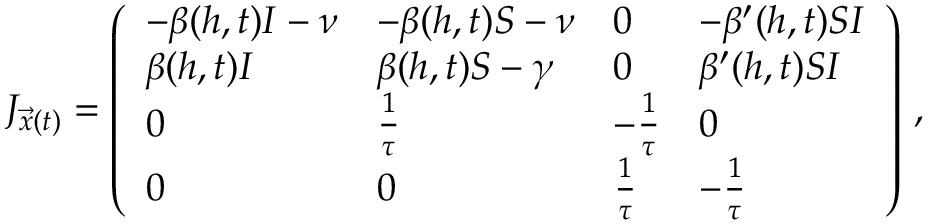Convert formula to latex. <formula><loc_0><loc_0><loc_500><loc_500>J _ { \vec { x } ( t ) } = \left ( \begin{array} { l l l l } { - \beta ( h , t ) I - \nu } & { - \beta ( h , t ) S - \nu } & { 0 } & { - \beta ^ { \prime } ( h , t ) S I } \\ { \beta ( h , t ) I } & { \beta ( h , t ) S - \gamma } & { 0 } & { \beta ^ { \prime } ( h , t ) S I } \\ { 0 } & { \frac { 1 } { \tau } } & { - \frac { 1 } { \tau } } & { 0 } \\ { 0 } & { 0 } & { \frac { 1 } { \tau } } & { - \frac { 1 } { \tau } } \end{array} \right ) \, ,</formula> 